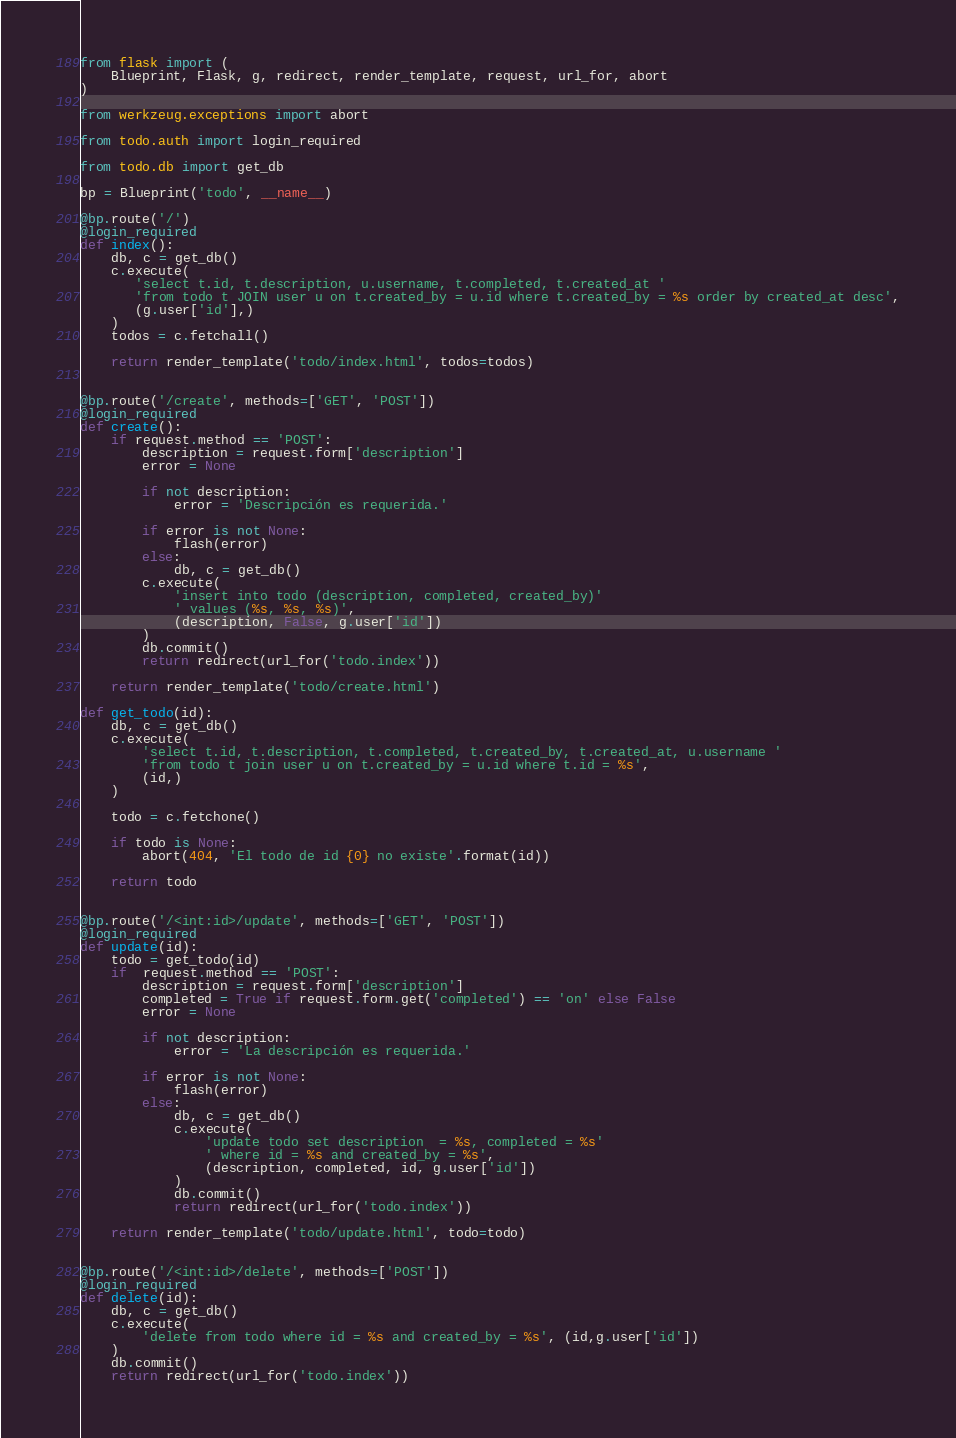Convert code to text. <code><loc_0><loc_0><loc_500><loc_500><_Python_>from flask import (
    Blueprint, Flask, g, redirect, render_template, request, url_for, abort
)

from werkzeug.exceptions import abort

from todo.auth import login_required

from todo.db import get_db

bp = Blueprint('todo', __name__)

@bp.route('/')
@login_required
def index():
    db, c = get_db()
    c.execute(
       'select t.id, t.description, u.username, t.completed, t.created_at '
       'from todo t JOIN user u on t.created_by = u.id where t.created_by = %s order by created_at desc',
       (g.user['id'],)
    )
    todos = c.fetchall()

    return render_template('todo/index.html', todos=todos)


@bp.route('/create', methods=['GET', 'POST'])
@login_required
def create():
    if request.method == 'POST':
        description = request.form['description']
        error = None

        if not description:
            error = 'Descripción es requerida.'

        if error is not None:
            flash(error)
        else:
            db, c = get_db()
        c.execute(
            'insert into todo (description, completed, created_by)'
            ' values (%s, %s, %s)',
            (description, False, g.user['id'])
        )
        db.commit()
        return redirect(url_for('todo.index'))

    return render_template('todo/create.html')

def get_todo(id):
    db, c = get_db()
    c.execute(
        'select t.id, t.description, t.completed, t.created_by, t.created_at, u.username '
        'from todo t join user u on t.created_by = u.id where t.id = %s',
        (id,)
    )

    todo = c.fetchone()

    if todo is None:
        abort(404, 'El todo de id {0} no existe'.format(id))

    return todo


@bp.route('/<int:id>/update', methods=['GET', 'POST'])
@login_required
def update(id):
    todo = get_todo(id)
    if  request.method == 'POST':
        description = request.form['description']
        completed = True if request.form.get('completed') == 'on' else False
        error = None

        if not description:
            error = 'La descripción es requerida.'

        if error is not None:
            flash(error)
        else: 
            db, c = get_db()
            c.execute(
                'update todo set description  = %s, completed = %s'
                ' where id = %s and created_by = %s',
                (description, completed, id, g.user['id'])
            )
            db.commit()
            return redirect(url_for('todo.index'))

    return render_template('todo/update.html', todo=todo)


@bp.route('/<int:id>/delete', methods=['POST'])
@login_required
def delete(id):
    db, c = get_db()
    c.execute(
        'delete from todo where id = %s and created_by = %s', (id,g.user['id'])
    )
    db.commit()
    return redirect(url_for('todo.index'))</code> 